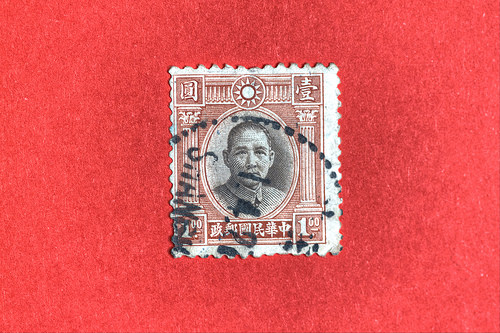<image>
Is there a stamp in front of the stamp? Yes. The stamp is positioned in front of the stamp, appearing closer to the camera viewpoint. 